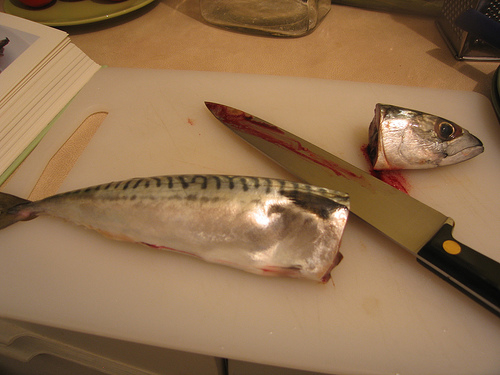<image>
Is the fish head on the table? Yes. Looking at the image, I can see the fish head is positioned on top of the table, with the table providing support. Where is the fish in relation to the cutting board? Is it on the cutting board? Yes. Looking at the image, I can see the fish is positioned on top of the cutting board, with the cutting board providing support. Is the fish behind the knife? Yes. From this viewpoint, the fish is positioned behind the knife, with the knife partially or fully occluding the fish. 